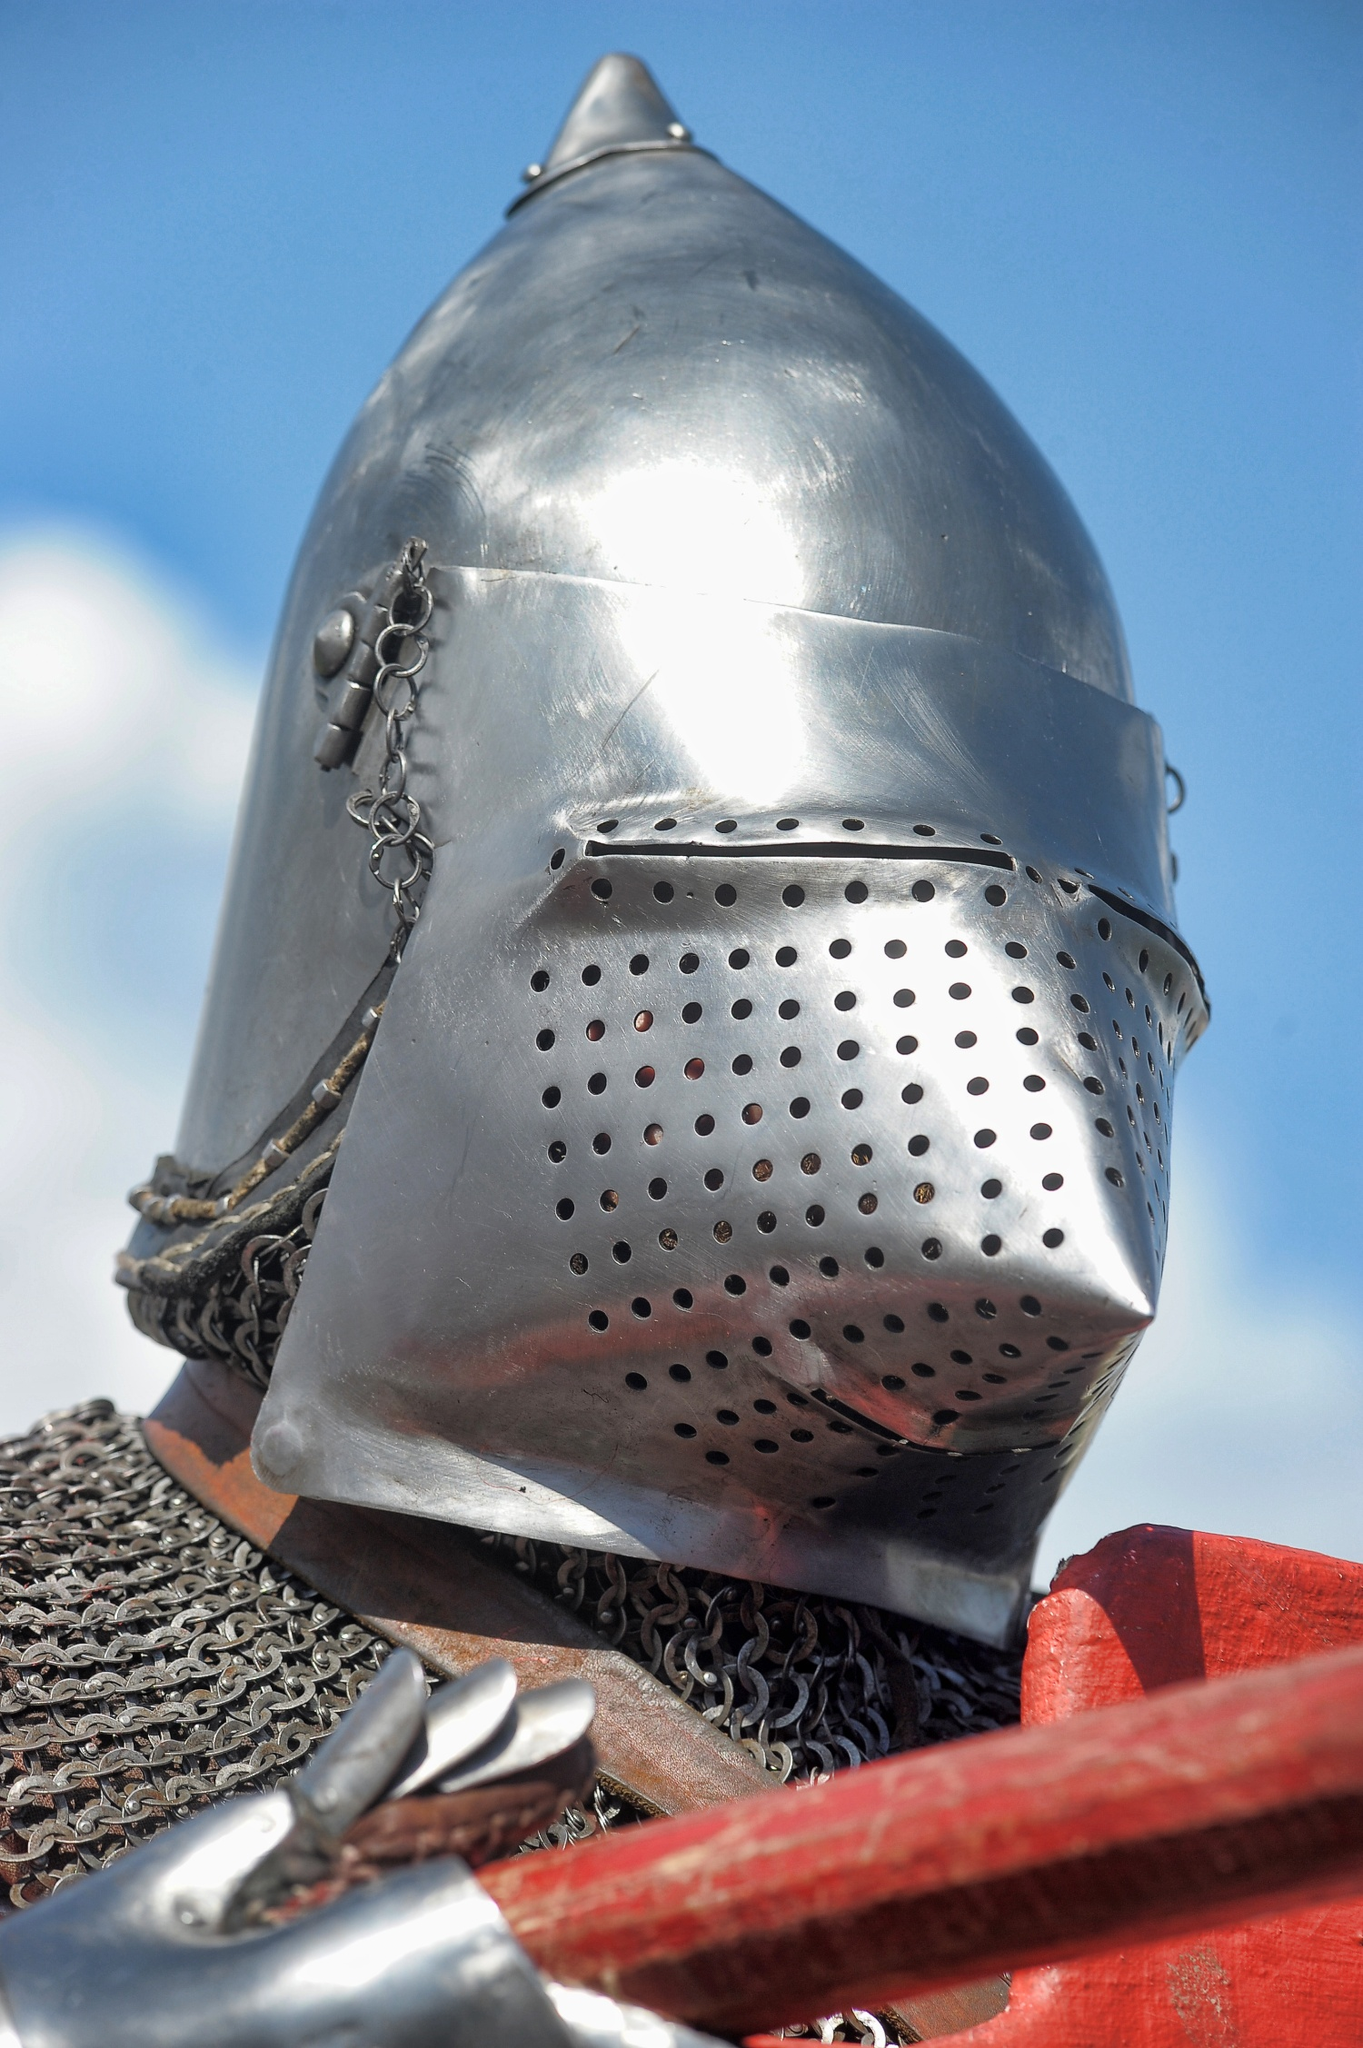What do you think is going on in this snapshot? The photograph shows a close-up of a knight's helmet, designed with historical accuracy to resemble medieval armory. The helmet, suspended and not worn, gleams in natural sunlight, showcasing its conical shape and the intricate detail of the chainmail neck guard. The perforated faceplate indicates that it's designed for both protection and functionality, allowing the wearer to see and breathe. This helmet is placed on a red wooden structure, seemingly at an exhibit or historical display, given the pristine condition of the metal and the way it's presented. The sky serves as a backdrop, emphasizing the craftsmanship of the armor and possibly suggesting this image was taken at an outdoor event or renaissance fair. 